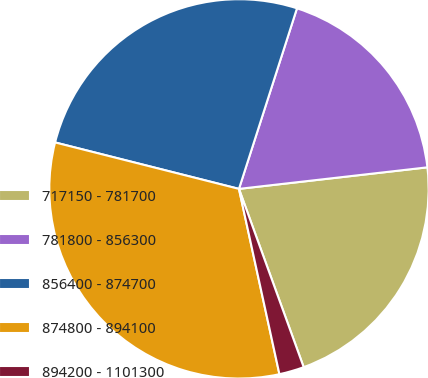<chart> <loc_0><loc_0><loc_500><loc_500><pie_chart><fcel>717150 - 781700<fcel>781800 - 856300<fcel>856400 - 874700<fcel>874800 - 894100<fcel>894200 - 1101300<nl><fcel>21.27%<fcel>18.24%<fcel>26.01%<fcel>32.36%<fcel>2.12%<nl></chart> 